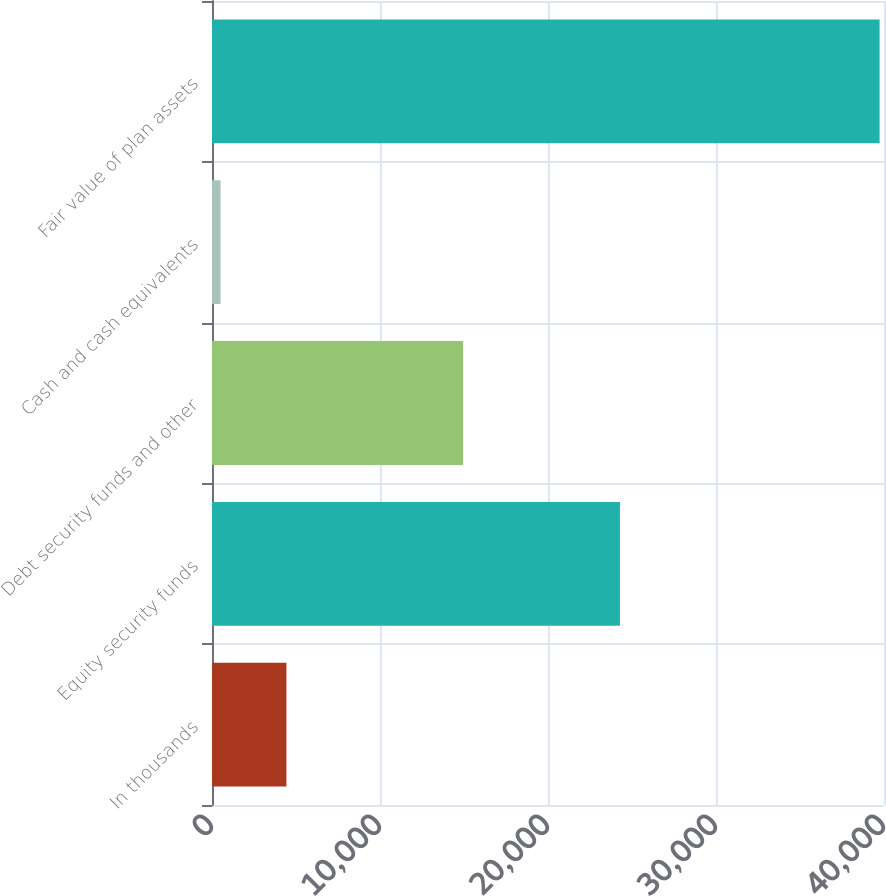Convert chart. <chart><loc_0><loc_0><loc_500><loc_500><bar_chart><fcel>In thousands<fcel>Equity security funds<fcel>Debt security funds and other<fcel>Cash and cash equivalents<fcel>Fair value of plan assets<nl><fcel>4431.9<fcel>24282<fcel>14947<fcel>509<fcel>39738<nl></chart> 